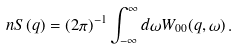<formula> <loc_0><loc_0><loc_500><loc_500>n S ( q ) = ( 2 \pi ) ^ { - 1 } \int _ { - \infty } ^ { \infty } d \omega W _ { 0 0 } ( q , \omega ) \, .</formula> 